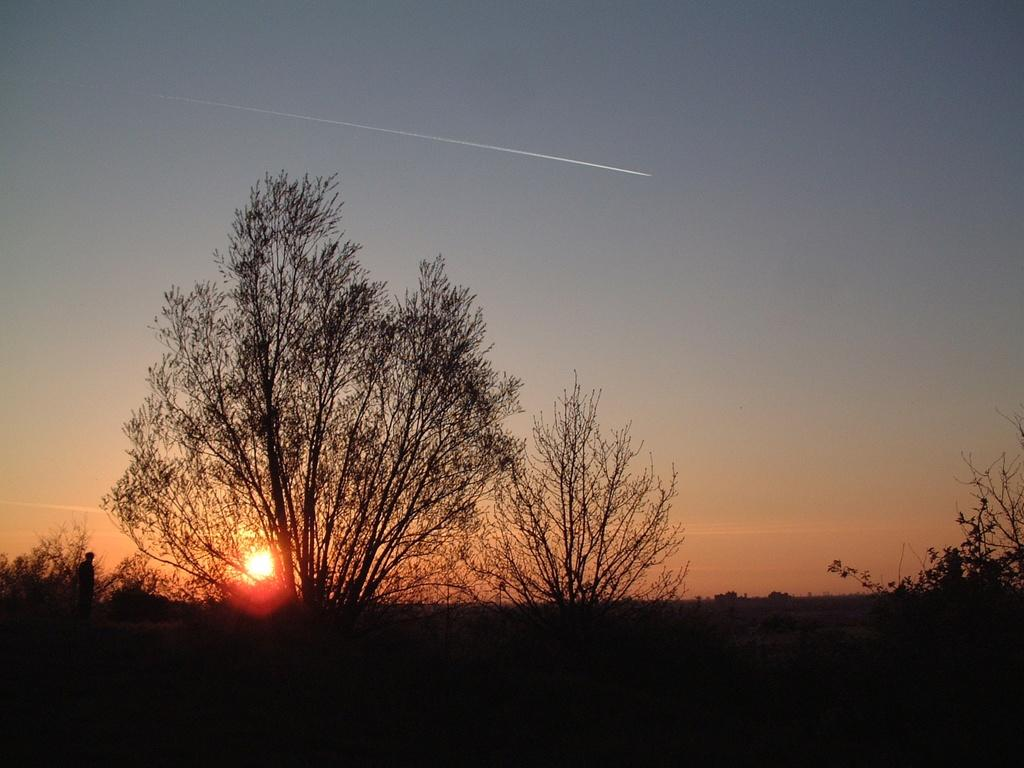What is the main subject of the image? There is a person standing in the image. What can be seen in the background of the image? There are trees and the sun visible in the background of the image. How would you describe the weather based on the image? The sky is clear in the background of the image, suggesting good weather. How many dolls are sitting on the skateboard in the image? There are no dolls or skateboards present in the image. 